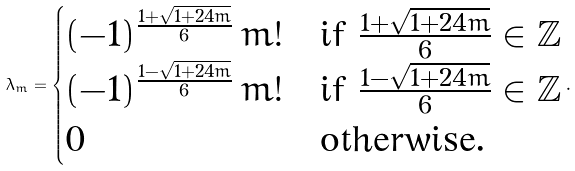<formula> <loc_0><loc_0><loc_500><loc_500>\lambda _ { m } = \begin{cases} ( - 1 ) ^ { \frac { 1 + \sqrt { 1 + 2 4 m } } { 6 } } \, m ! & \text {if $\frac{1+\sqrt{1+24m}}{6}\in \mathbb{Z}$} \\ ( - 1 ) ^ { \frac { 1 - \sqrt { 1 + 2 4 m } } { 6 } } \, m ! & \text {if $\frac{1-\sqrt{1+24m}}{6}\in \mathbb{Z}$} \\ 0 & \text {otherwise} . \end{cases} .</formula> 